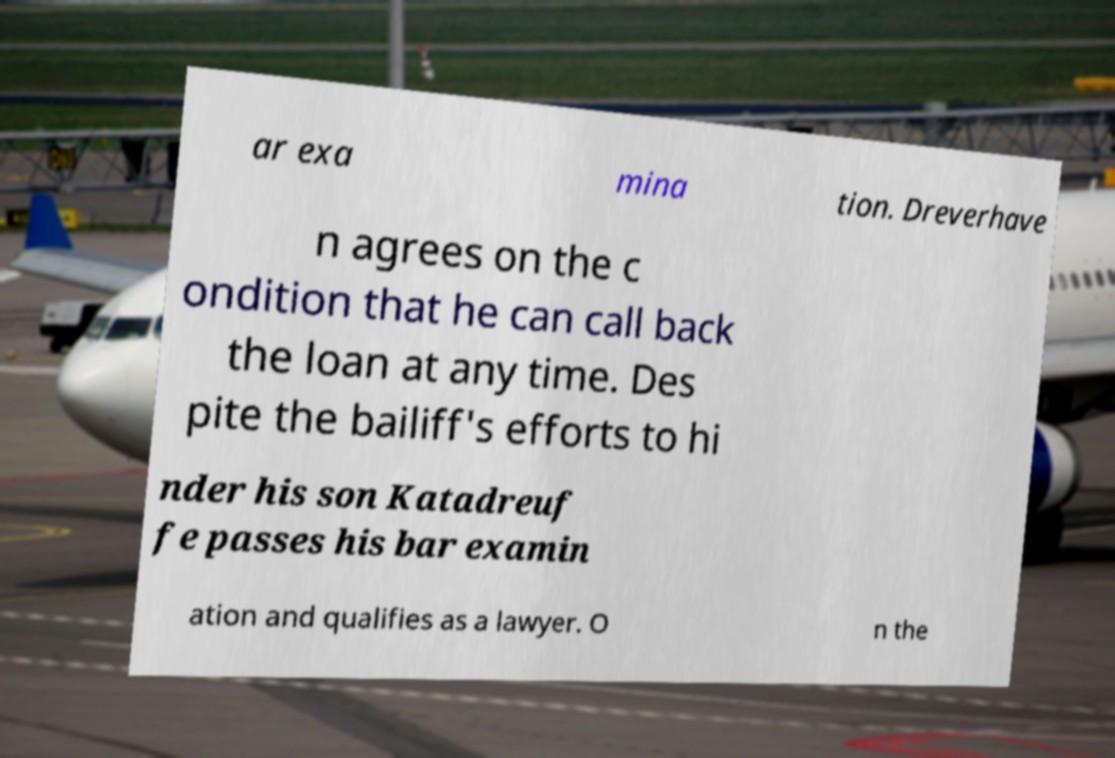Can you accurately transcribe the text from the provided image for me? ar exa mina tion. Dreverhave n agrees on the c ondition that he can call back the loan at any time. Des pite the bailiff's efforts to hi nder his son Katadreuf fe passes his bar examin ation and qualifies as a lawyer. O n the 